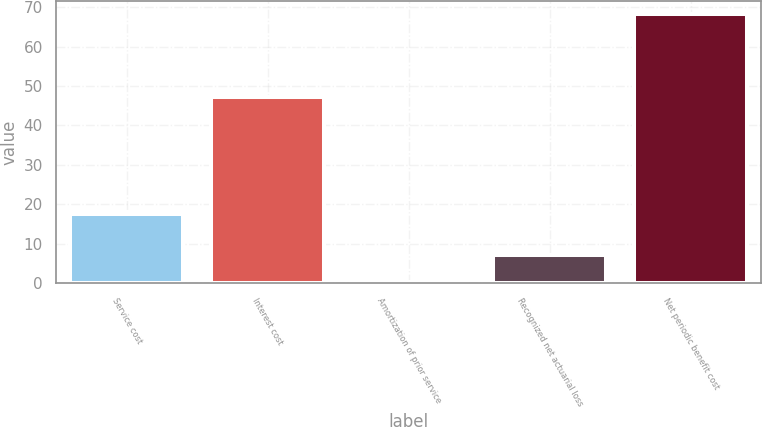Convert chart to OTSL. <chart><loc_0><loc_0><loc_500><loc_500><bar_chart><fcel>Service cost<fcel>Interest cost<fcel>Amortization of prior service<fcel>Recognized net actuarial loss<fcel>Net periodic benefit cost<nl><fcel>17.4<fcel>47.1<fcel>0.2<fcel>7<fcel>68.2<nl></chart> 